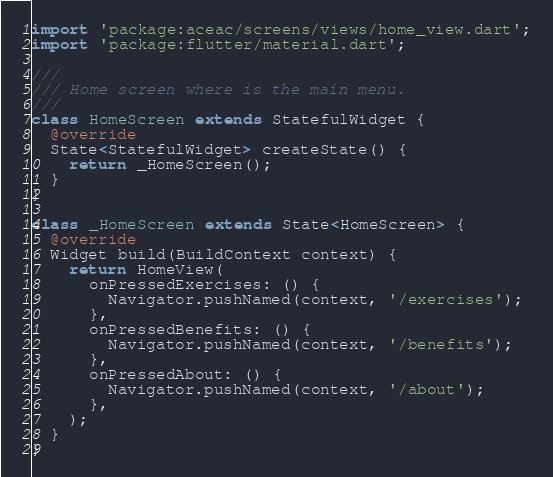<code> <loc_0><loc_0><loc_500><loc_500><_Dart_>import 'package:aceac/screens/views/home_view.dart';
import 'package:flutter/material.dart';

///
/// Home screen where is the main menu.
///
class HomeScreen extends StatefulWidget {
  @override
  State<StatefulWidget> createState() {
    return _HomeScreen();
  }
}

class _HomeScreen extends State<HomeScreen> {
  @override
  Widget build(BuildContext context) {
    return HomeView(
      onPressedExercises: () {
        Navigator.pushNamed(context, '/exercises');
      },
      onPressedBenefits: () {
        Navigator.pushNamed(context, '/benefits');
      },
      onPressedAbout: () {
        Navigator.pushNamed(context, '/about');
      },
    );
  }
}
</code> 